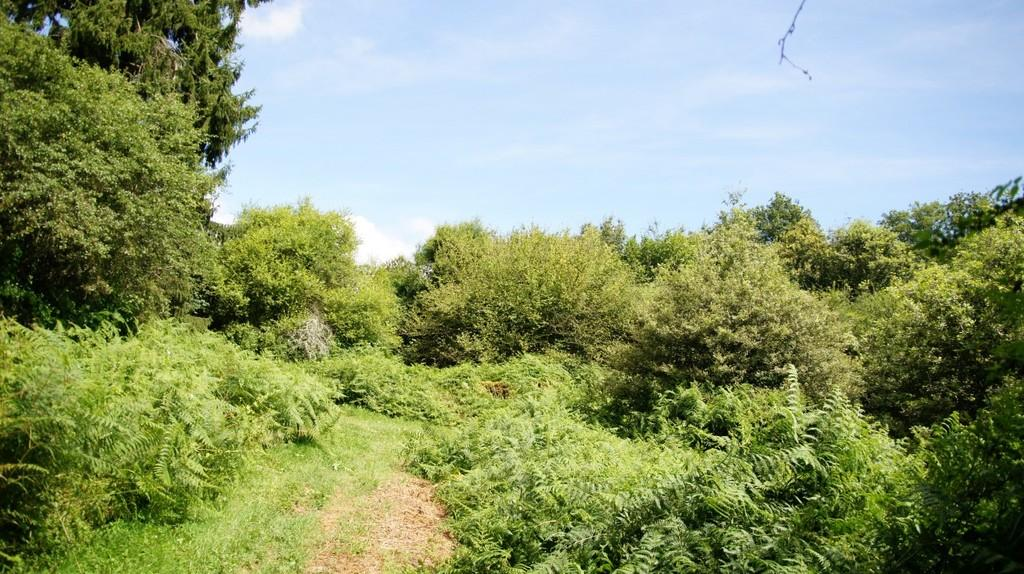What type of vegetation can be seen in the image? There are plants and trees in the image. What is covering the ground in the image? There is grass on the ground in the image. What feature is present in the center of the image? There is a path in the center of the image. What is visible at the top of the image? The sky is visible at the top of the image. What acoustics can be heard in the image? There are no sounds or acoustics present in the image, as it is a still photograph. What rule is being enforced by the trees in the image? There is no rule being enforced by the trees in the image; they are simply part of the natural landscape. 